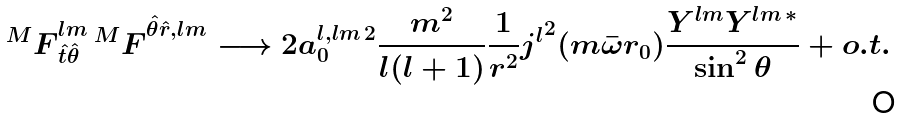Convert formula to latex. <formula><loc_0><loc_0><loc_500><loc_500>\, { ^ { M } F } _ { \hat { t } \hat { \theta } } ^ { l m } \, { ^ { M } F } ^ { \hat { \theta } \hat { r } , l m } \longrightarrow 2 a _ { 0 } ^ { l , l m \, 2 } \frac { m ^ { 2 } } { l ( l + 1 ) } \frac { 1 } { r ^ { 2 } } { j ^ { l } } ^ { 2 } ( m \bar { \omega } r _ { 0 } ) \frac { Y ^ { l m } Y ^ { l m \, * } } { \sin ^ { 2 } \theta } + o . t .</formula> 